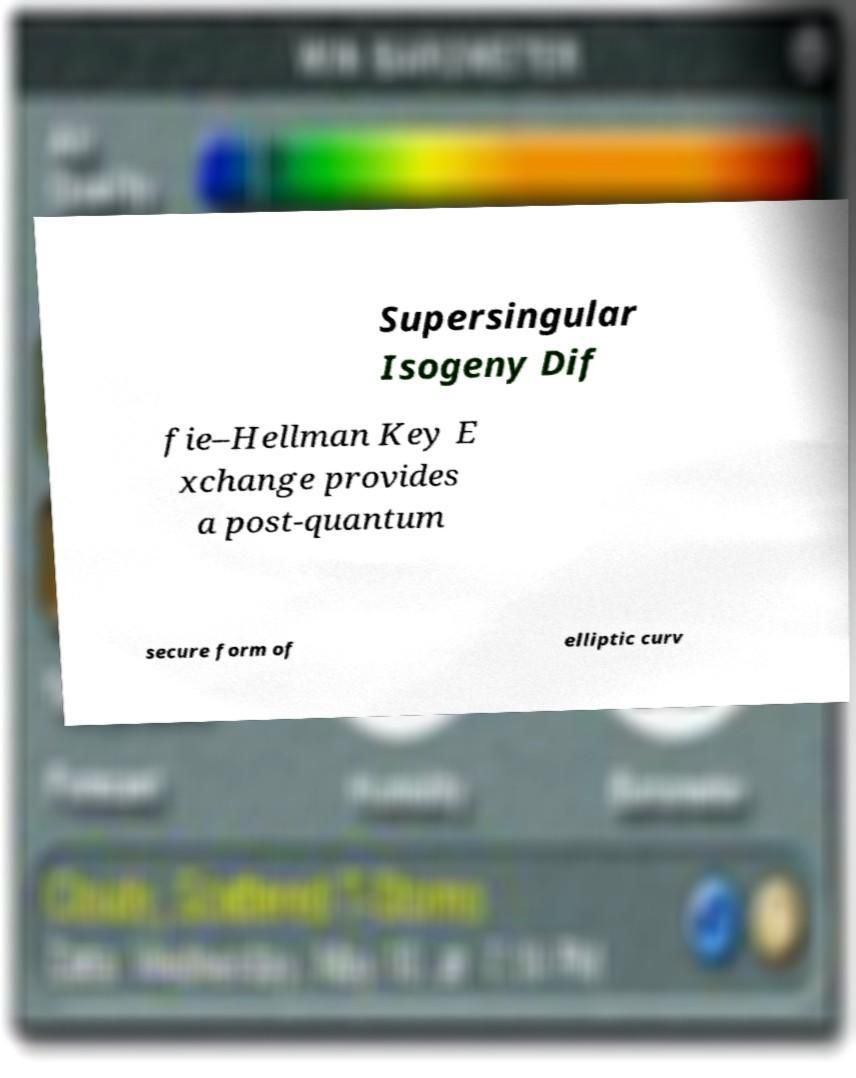Can you read and provide the text displayed in the image?This photo seems to have some interesting text. Can you extract and type it out for me? Supersingular Isogeny Dif fie–Hellman Key E xchange provides a post-quantum secure form of elliptic curv 